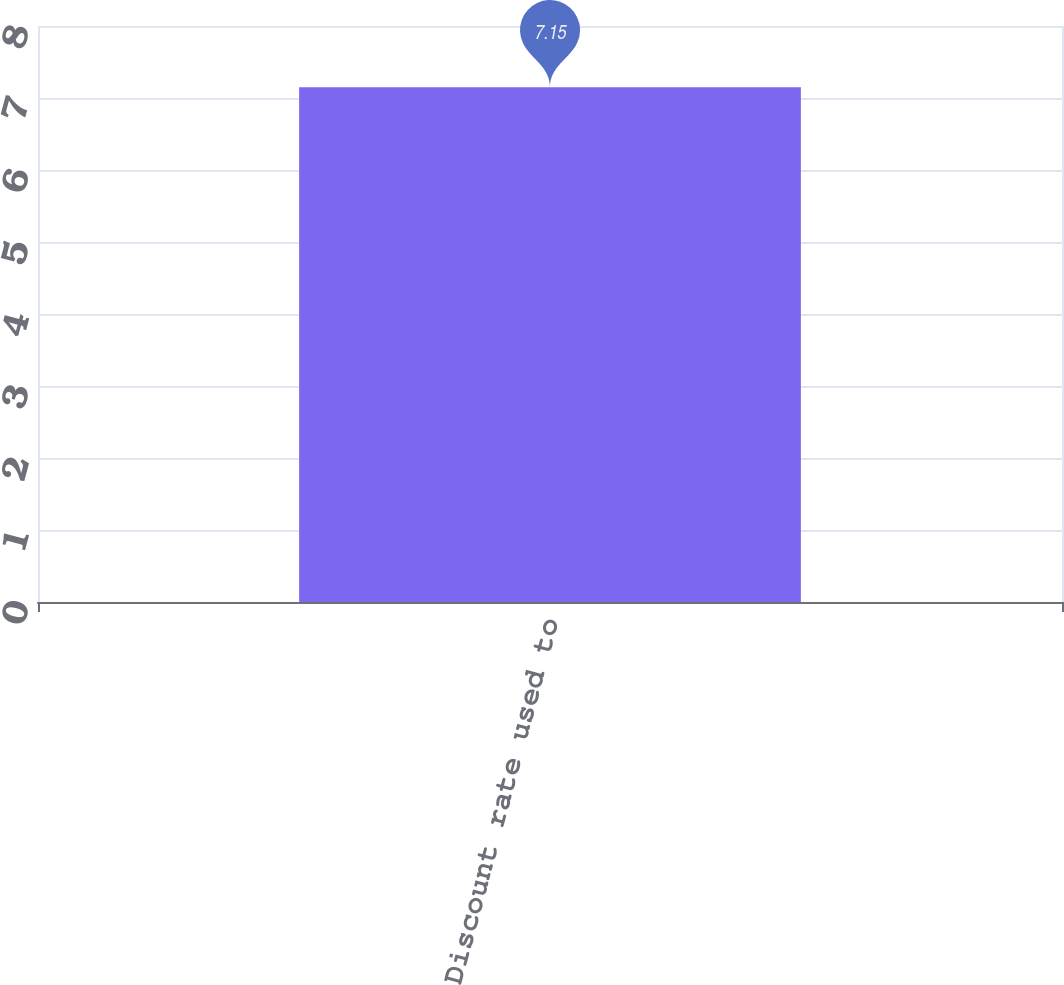Convert chart to OTSL. <chart><loc_0><loc_0><loc_500><loc_500><bar_chart><fcel>Discount rate used to<nl><fcel>7.15<nl></chart> 